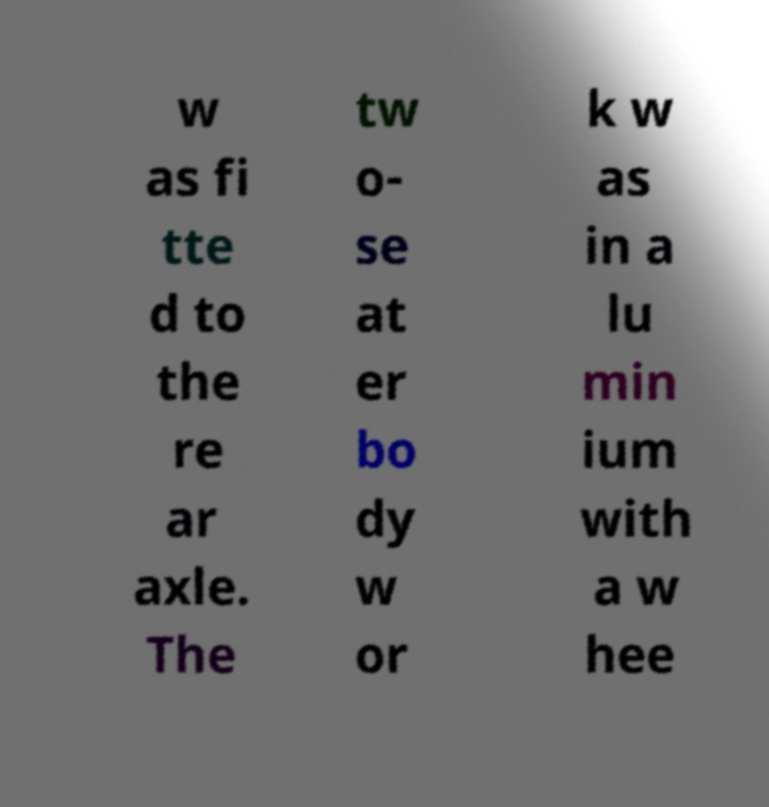I need the written content from this picture converted into text. Can you do that? w as fi tte d to the re ar axle. The tw o- se at er bo dy w or k w as in a lu min ium with a w hee 